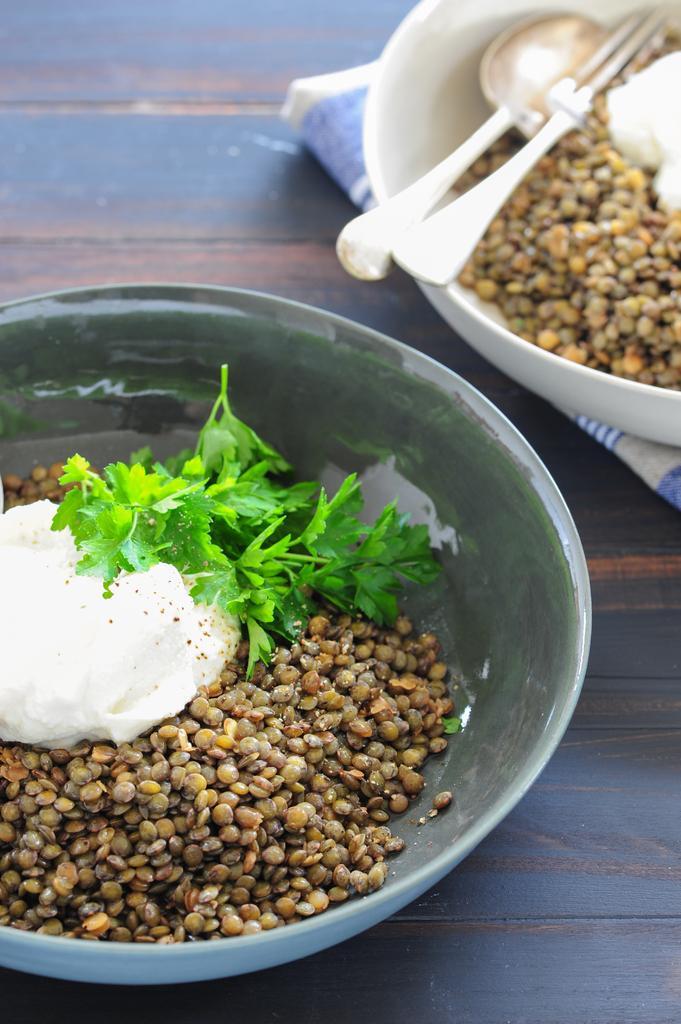In one or two sentences, can you explain what this image depicts? In this image I can see the black and brown colored table and on it I can see a bowl with few grains, a white colored cream and few herbs. I can see another bowl on the cloth and in the bowl I can see few grains, few spoons and a white colored cream. 